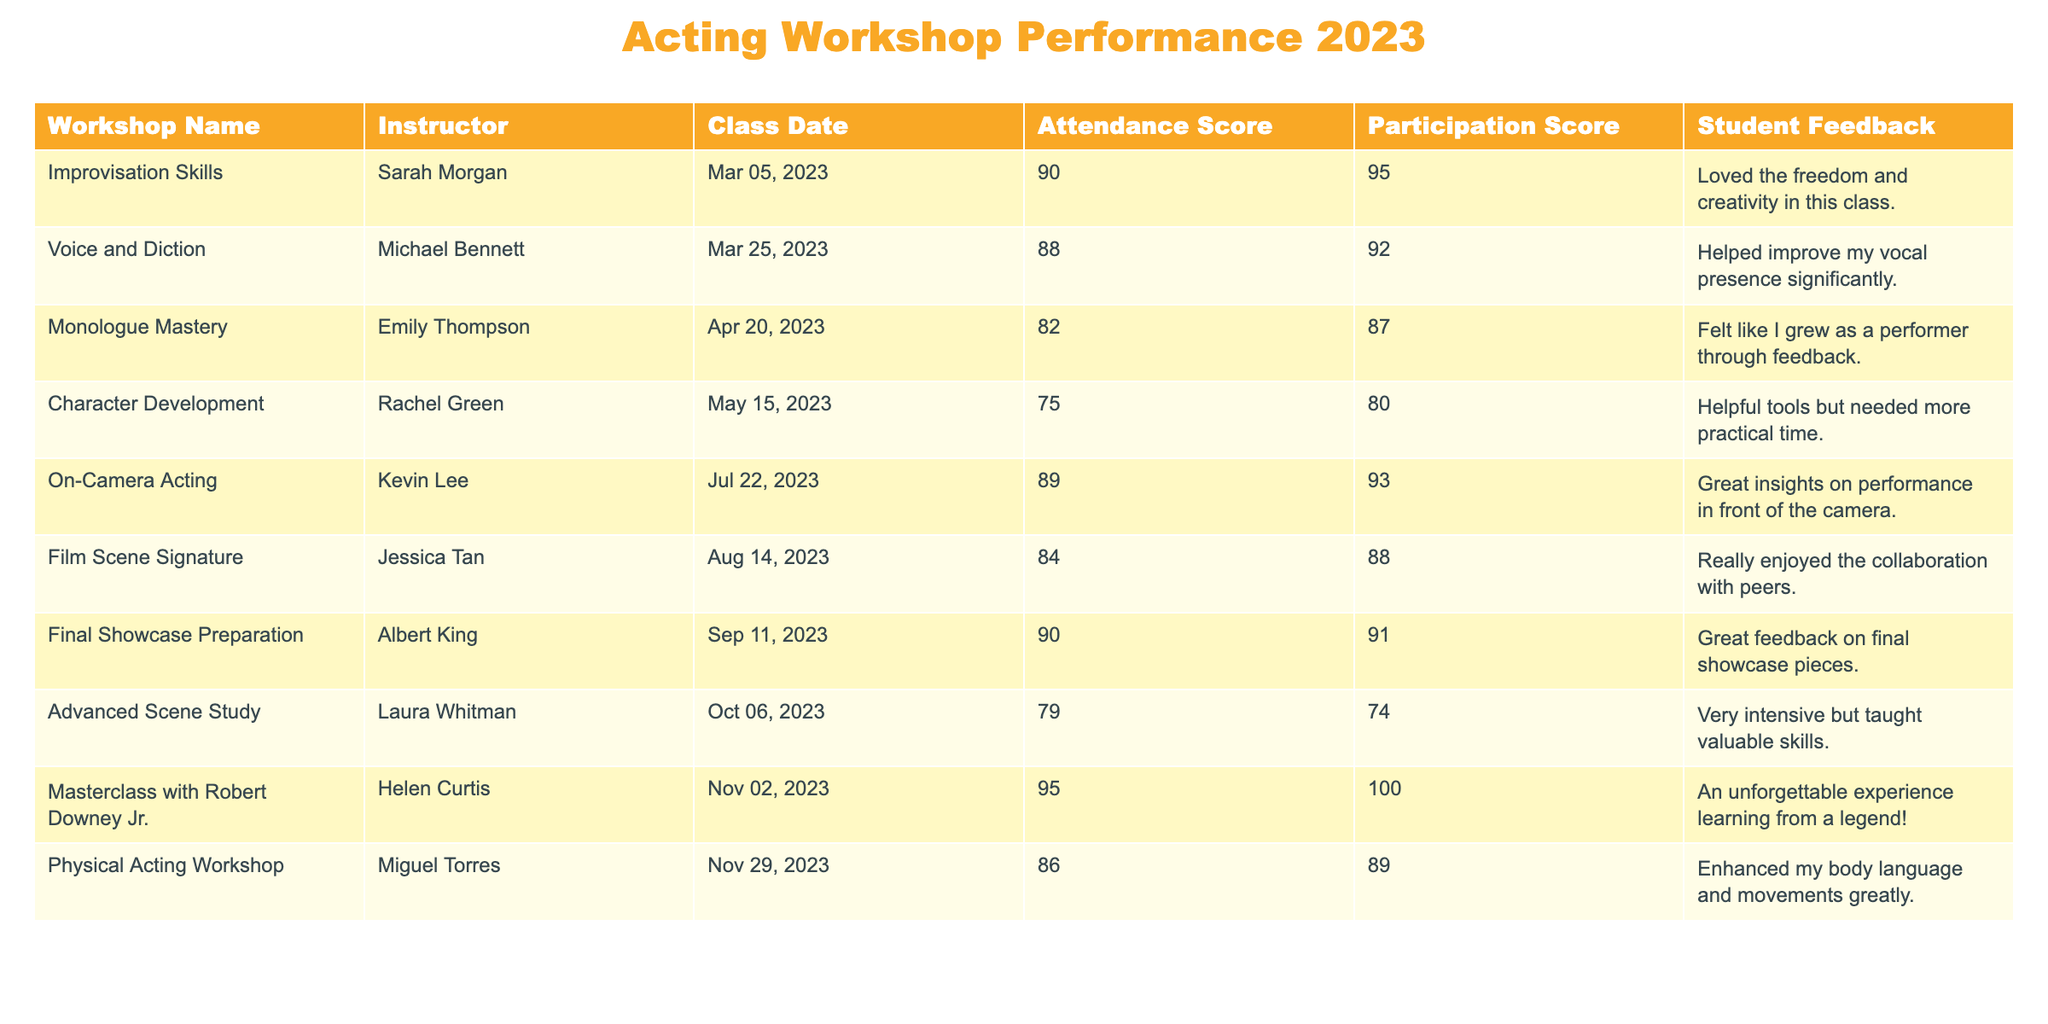What was the highest attendance score recorded? The table lists the attendance scores for each workshop. Upon reviewing the scores, the highest recorded attendance score is 95.
Answer: 95 Who was the instructor for the "Masterclass with Robert Downey Jr."? According to the table, the instructor for that workshop is Helen Curtis.
Answer: Helen Curtis What is the average participation score of the workshops held in 2023? To find the average participation score, we sum all the participation scores: 95 + 92 + 87 + 80 + 93 + 88 + 91 + 74 + 100 + 89 = 919, then divide by the number of workshops (10), which gives us 919 / 10 = 91.9.
Answer: 91.9 Did the "Advanced Scene Study" workshop receive a participation score higher than 80? By checking the table, the participation score for the "Advanced Scene Study" workshop is 74, which is lower than 80.
Answer: No Which workshop had the lowest attendance score and what was it? Looking at the attendance scores in the table, "Character Development" had the lowest score of 75.
Answer: 75 What is the difference between the highest and lowest participation scores? The highest participation score in the table is 100 (from the masterclass), and the lowest is 74 (from the advanced scene study). The difference is 100 - 74 = 26.
Answer: 26 Which workshop received the best student feedback? Based on the feedback in the table, "Masterclass with Robert Downey Jr." received the most enthusiastic feedback, described as "An unforgettable experience."
Answer: Masterclass with Robert Downey Jr How many workshops had an attendance score of 85 or higher? By counting the workshops with attendance scores of 85 or higher, we find "Improvisation Skills," "On-Camera Acting," "Final Showcase Preparation," and "Masterclass with Robert Downey Jr." which totals 4 workshops.
Answer: 4 What was the total attendance score for all workshops combined? The sum of all attendance scores in the table is: 90 + 88 + 82 + 75 + 89 + 84 + 90 + 79 + 95 + 86 =  888.
Answer: 888 Was there a workshop that had both attendance and participation scores above 90? Yes, the "Masterclass with Robert Downey Jr." had both scores above 90, with an attendance score of 95 and a participation score of 100.
Answer: Yes 